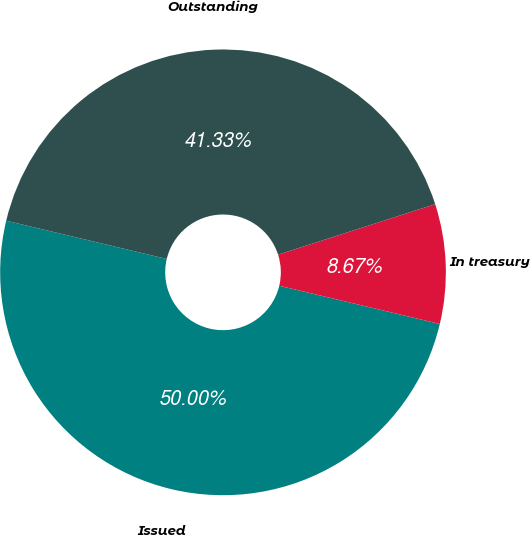Convert chart. <chart><loc_0><loc_0><loc_500><loc_500><pie_chart><fcel>Issued<fcel>In treasury<fcel>Outstanding<nl><fcel>50.0%<fcel>8.67%<fcel>41.33%<nl></chart> 